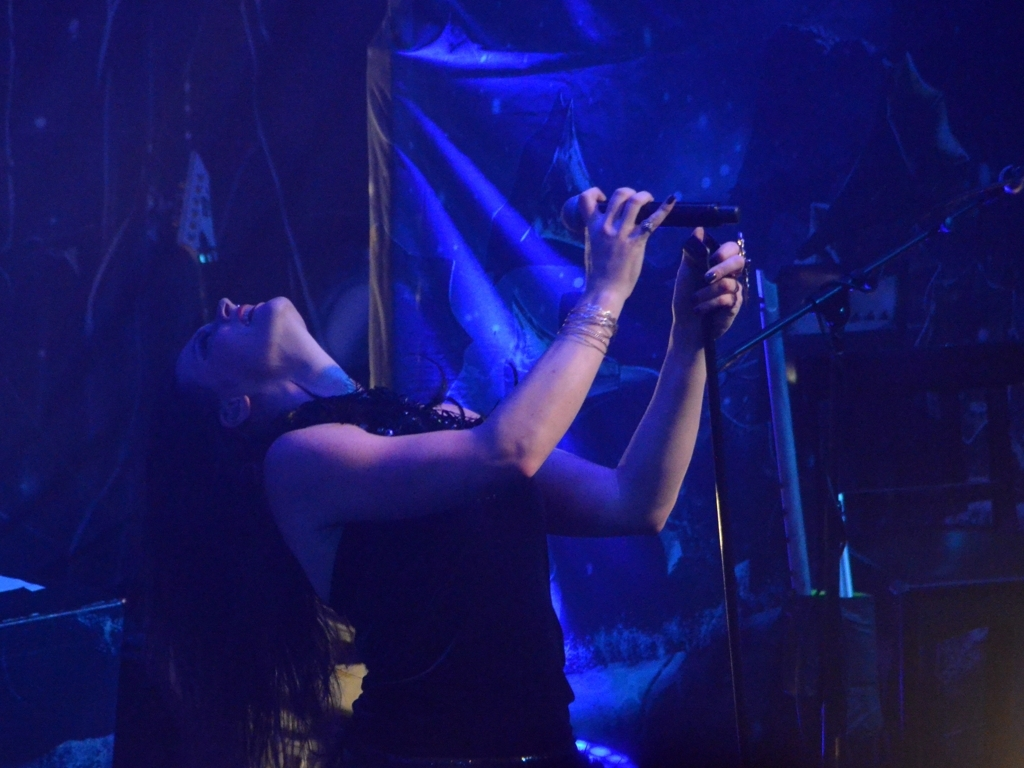How does the lighting affect the scene? The blue and purple lighting creates a moody and mysterious ambiance. It highlights the performer while casting soft shadows, adding depth and focus to the scene. 